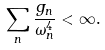Convert formula to latex. <formula><loc_0><loc_0><loc_500><loc_500>\sum _ { n } \frac { g _ { n } } { \omega _ { n } ^ { 4 } } < \infty .</formula> 